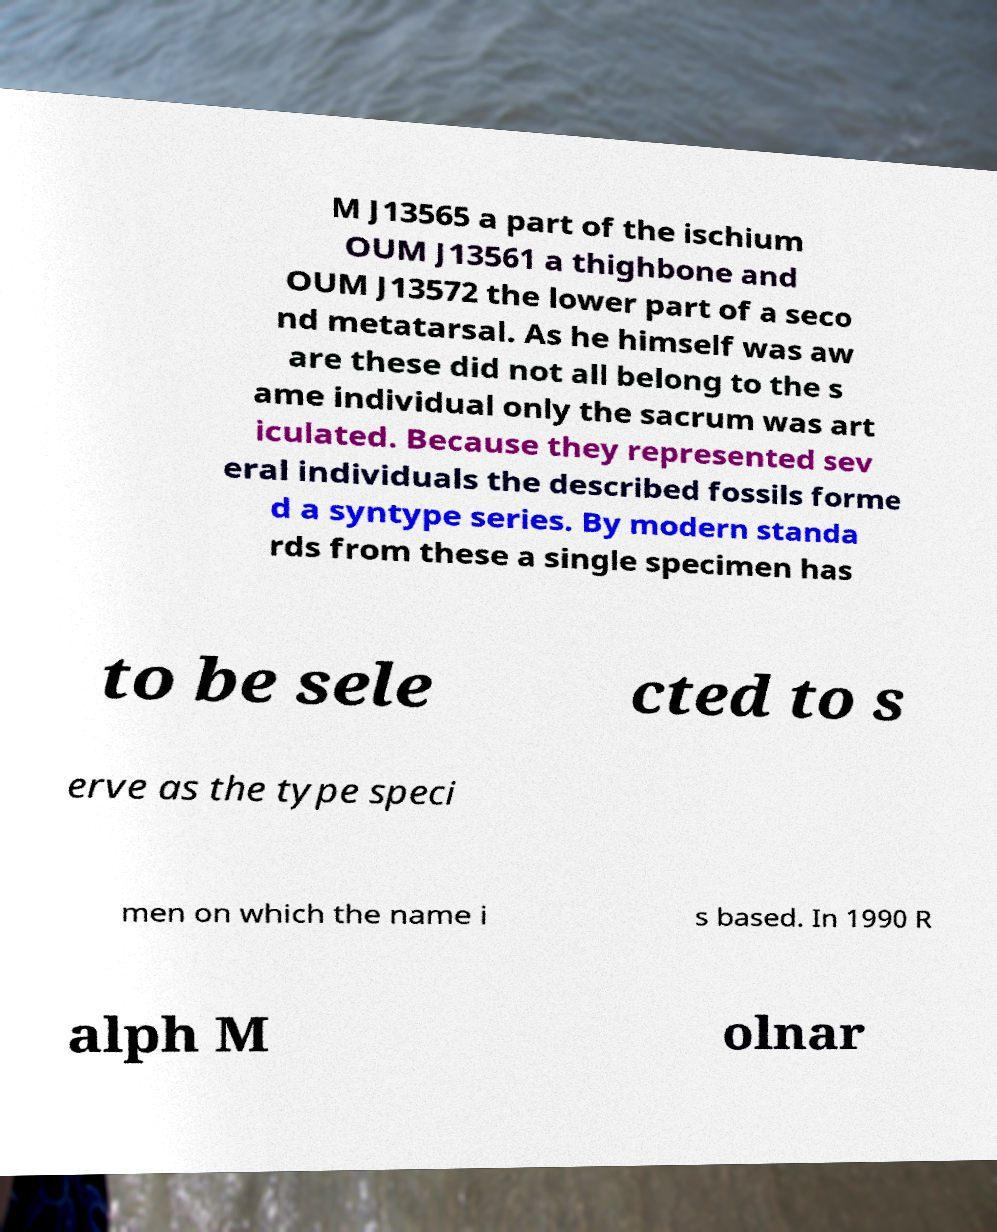Please read and relay the text visible in this image. What does it say? M J13565 a part of the ischium OUM J13561 a thighbone and OUM J13572 the lower part of a seco nd metatarsal. As he himself was aw are these did not all belong to the s ame individual only the sacrum was art iculated. Because they represented sev eral individuals the described fossils forme d a syntype series. By modern standa rds from these a single specimen has to be sele cted to s erve as the type speci men on which the name i s based. In 1990 R alph M olnar 